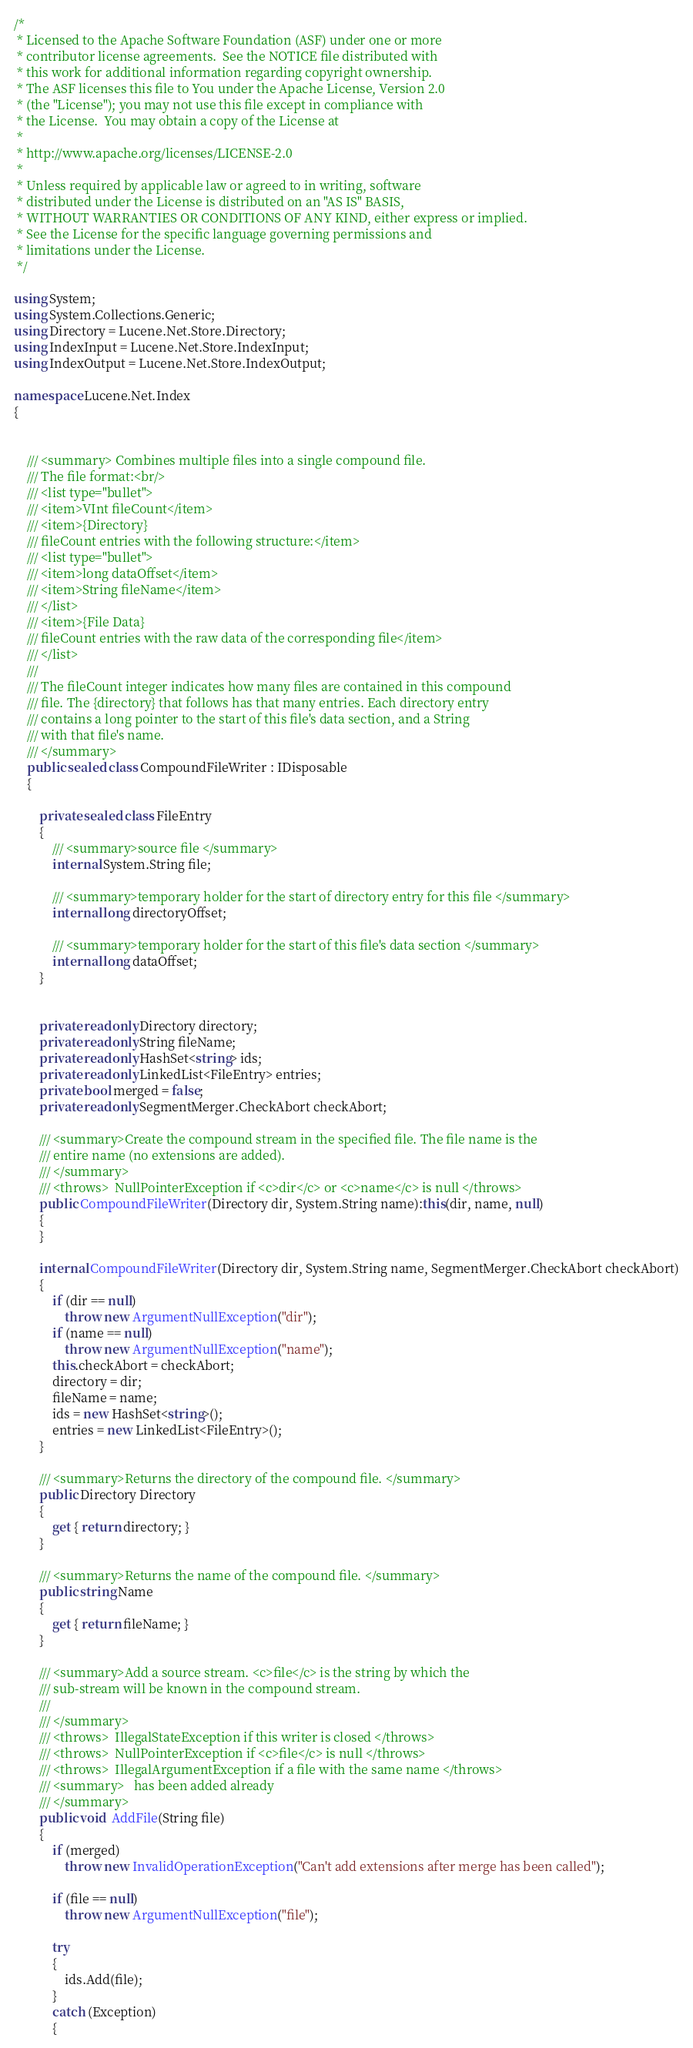Convert code to text. <code><loc_0><loc_0><loc_500><loc_500><_C#_>/* 
 * Licensed to the Apache Software Foundation (ASF) under one or more
 * contributor license agreements.  See the NOTICE file distributed with
 * this work for additional information regarding copyright ownership.
 * The ASF licenses this file to You under the Apache License, Version 2.0
 * (the "License"); you may not use this file except in compliance with
 * the License.  You may obtain a copy of the License at
 * 
 * http://www.apache.org/licenses/LICENSE-2.0
 * 
 * Unless required by applicable law or agreed to in writing, software
 * distributed under the License is distributed on an "AS IS" BASIS,
 * WITHOUT WARRANTIES OR CONDITIONS OF ANY KIND, either express or implied.
 * See the License for the specific language governing permissions and
 * limitations under the License.
 */

using System;
using System.Collections.Generic;
using Directory = Lucene.Net.Store.Directory;
using IndexInput = Lucene.Net.Store.IndexInput;
using IndexOutput = Lucene.Net.Store.IndexOutput;

namespace Lucene.Net.Index
{
    
    
    /// <summary> Combines multiple files into a single compound file.
    /// The file format:<br/>
    /// <list type="bullet">
    /// <item>VInt fileCount</item>
    /// <item>{Directory}
    /// fileCount entries with the following structure:</item>
    /// <list type="bullet">
    /// <item>long dataOffset</item>
    /// <item>String fileName</item>
    /// </list>
    /// <item>{File Data}
    /// fileCount entries with the raw data of the corresponding file</item>
    /// </list>
    /// 
    /// The fileCount integer indicates how many files are contained in this compound
    /// file. The {directory} that follows has that many entries. Each directory entry
    /// contains a long pointer to the start of this file's data section, and a String
    /// with that file's name.
    /// </summary>
    public sealed class CompoundFileWriter : IDisposable
    {
        
        private sealed class FileEntry
        {
            /// <summary>source file </summary>
            internal System.String file;
            
            /// <summary>temporary holder for the start of directory entry for this file </summary>
            internal long directoryOffset;
            
            /// <summary>temporary holder for the start of this file's data section </summary>
            internal long dataOffset;
        }
        
        
        private readonly Directory directory;
        private readonly String fileName;
        private readonly HashSet<string> ids;
        private readonly LinkedList<FileEntry> entries;
        private bool merged = false;
        private readonly SegmentMerger.CheckAbort checkAbort;
        
        /// <summary>Create the compound stream in the specified file. The file name is the
        /// entire name (no extensions are added).
        /// </summary>
        /// <throws>  NullPointerException if <c>dir</c> or <c>name</c> is null </throws>
        public CompoundFileWriter(Directory dir, System.String name):this(dir, name, null)
        {
        }
        
        internal CompoundFileWriter(Directory dir, System.String name, SegmentMerger.CheckAbort checkAbort)
        {
            if (dir == null)
                throw new ArgumentNullException("dir");
            if (name == null)
                throw new ArgumentNullException("name");
            this.checkAbort = checkAbort;
            directory = dir;
            fileName = name;
            ids = new HashSet<string>();
            entries = new LinkedList<FileEntry>();
        }

        /// <summary>Returns the directory of the compound file. </summary>
        public Directory Directory
        {
            get { return directory; }
        }

        /// <summary>Returns the name of the compound file. </summary>
        public string Name
        {
            get { return fileName; }
        }

        /// <summary>Add a source stream. <c>file</c> is the string by which the 
        /// sub-stream will be known in the compound stream.
        /// 
        /// </summary>
        /// <throws>  IllegalStateException if this writer is closed </throws>
        /// <throws>  NullPointerException if <c>file</c> is null </throws>
        /// <throws>  IllegalArgumentException if a file with the same name </throws>
        /// <summary>   has been added already
        /// </summary>
        public void  AddFile(String file)
        {
            if (merged)
                throw new InvalidOperationException("Can't add extensions after merge has been called");
            
            if (file == null)
                throw new ArgumentNullException("file");
            
            try
            {
                ids.Add(file);
            }
            catch (Exception)
            {</code> 